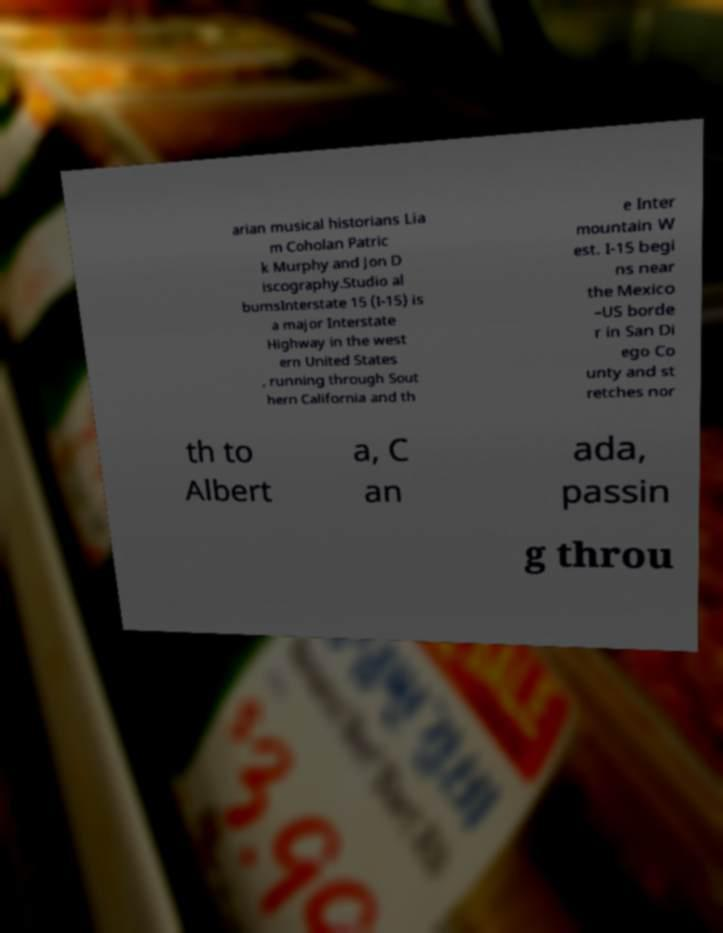Can you accurately transcribe the text from the provided image for me? arian musical historians Lia m Coholan Patric k Murphy and Jon D iscography.Studio al bumsInterstate 15 (I-15) is a major Interstate Highway in the west ern United States , running through Sout hern California and th e Inter mountain W est. I-15 begi ns near the Mexico –US borde r in San Di ego Co unty and st retches nor th to Albert a, C an ada, passin g throu 